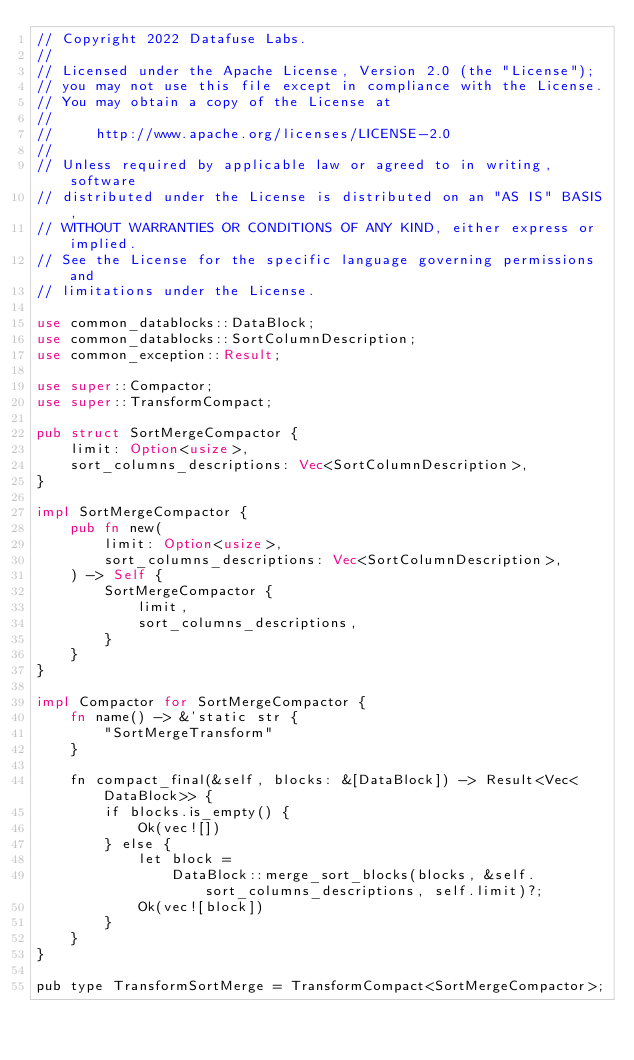Convert code to text. <code><loc_0><loc_0><loc_500><loc_500><_Rust_>// Copyright 2022 Datafuse Labs.
//
// Licensed under the Apache License, Version 2.0 (the "License");
// you may not use this file except in compliance with the License.
// You may obtain a copy of the License at
//
//     http://www.apache.org/licenses/LICENSE-2.0
//
// Unless required by applicable law or agreed to in writing, software
// distributed under the License is distributed on an "AS IS" BASIS,
// WITHOUT WARRANTIES OR CONDITIONS OF ANY KIND, either express or implied.
// See the License for the specific language governing permissions and
// limitations under the License.

use common_datablocks::DataBlock;
use common_datablocks::SortColumnDescription;
use common_exception::Result;

use super::Compactor;
use super::TransformCompact;

pub struct SortMergeCompactor {
    limit: Option<usize>,
    sort_columns_descriptions: Vec<SortColumnDescription>,
}

impl SortMergeCompactor {
    pub fn new(
        limit: Option<usize>,
        sort_columns_descriptions: Vec<SortColumnDescription>,
    ) -> Self {
        SortMergeCompactor {
            limit,
            sort_columns_descriptions,
        }
    }
}

impl Compactor for SortMergeCompactor {
    fn name() -> &'static str {
        "SortMergeTransform"
    }

    fn compact_final(&self, blocks: &[DataBlock]) -> Result<Vec<DataBlock>> {
        if blocks.is_empty() {
            Ok(vec![])
        } else {
            let block =
                DataBlock::merge_sort_blocks(blocks, &self.sort_columns_descriptions, self.limit)?;
            Ok(vec![block])
        }
    }
}

pub type TransformSortMerge = TransformCompact<SortMergeCompactor>;
</code> 